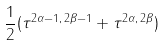<formula> <loc_0><loc_0><loc_500><loc_500>\frac { 1 } { 2 } ( \tau ^ { 2 \alpha - 1 , \, 2 \beta - 1 } + \tau ^ { 2 \alpha , \, 2 \beta } )</formula> 